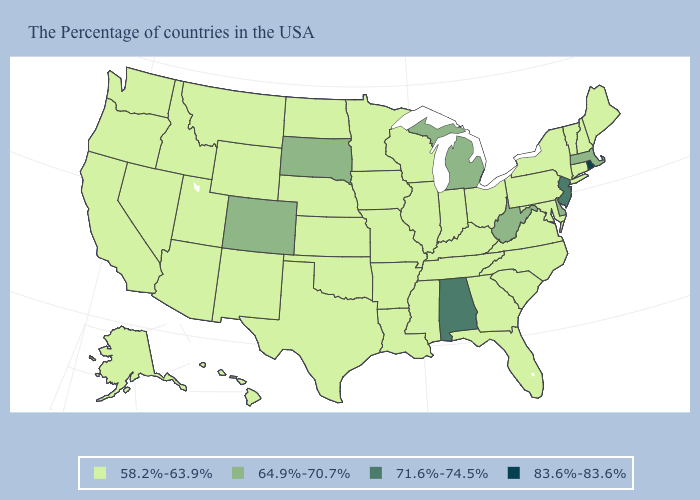Does the map have missing data?
Keep it brief. No. Among the states that border Wyoming , which have the lowest value?
Quick response, please. Nebraska, Utah, Montana, Idaho. Name the states that have a value in the range 58.2%-63.9%?
Short answer required. Maine, New Hampshire, Vermont, Connecticut, New York, Maryland, Pennsylvania, Virginia, North Carolina, South Carolina, Ohio, Florida, Georgia, Kentucky, Indiana, Tennessee, Wisconsin, Illinois, Mississippi, Louisiana, Missouri, Arkansas, Minnesota, Iowa, Kansas, Nebraska, Oklahoma, Texas, North Dakota, Wyoming, New Mexico, Utah, Montana, Arizona, Idaho, Nevada, California, Washington, Oregon, Alaska, Hawaii. Name the states that have a value in the range 58.2%-63.9%?
Be succinct. Maine, New Hampshire, Vermont, Connecticut, New York, Maryland, Pennsylvania, Virginia, North Carolina, South Carolina, Ohio, Florida, Georgia, Kentucky, Indiana, Tennessee, Wisconsin, Illinois, Mississippi, Louisiana, Missouri, Arkansas, Minnesota, Iowa, Kansas, Nebraska, Oklahoma, Texas, North Dakota, Wyoming, New Mexico, Utah, Montana, Arizona, Idaho, Nevada, California, Washington, Oregon, Alaska, Hawaii. What is the value of Montana?
Be succinct. 58.2%-63.9%. Does New Hampshire have the lowest value in the Northeast?
Give a very brief answer. Yes. Does the map have missing data?
Be succinct. No. Which states have the lowest value in the West?
Quick response, please. Wyoming, New Mexico, Utah, Montana, Arizona, Idaho, Nevada, California, Washington, Oregon, Alaska, Hawaii. Name the states that have a value in the range 83.6%-83.6%?
Give a very brief answer. Rhode Island. What is the highest value in states that border Kansas?
Answer briefly. 64.9%-70.7%. Name the states that have a value in the range 58.2%-63.9%?
Short answer required. Maine, New Hampshire, Vermont, Connecticut, New York, Maryland, Pennsylvania, Virginia, North Carolina, South Carolina, Ohio, Florida, Georgia, Kentucky, Indiana, Tennessee, Wisconsin, Illinois, Mississippi, Louisiana, Missouri, Arkansas, Minnesota, Iowa, Kansas, Nebraska, Oklahoma, Texas, North Dakota, Wyoming, New Mexico, Utah, Montana, Arizona, Idaho, Nevada, California, Washington, Oregon, Alaska, Hawaii. How many symbols are there in the legend?
Quick response, please. 4. What is the lowest value in the USA?
Write a very short answer. 58.2%-63.9%. Which states have the lowest value in the South?
Give a very brief answer. Maryland, Virginia, North Carolina, South Carolina, Florida, Georgia, Kentucky, Tennessee, Mississippi, Louisiana, Arkansas, Oklahoma, Texas. Does Montana have the highest value in the USA?
Answer briefly. No. 